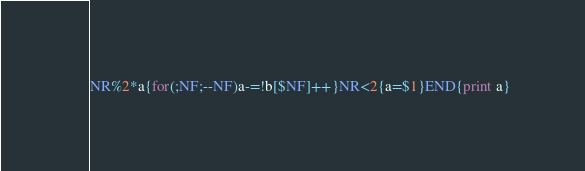Convert code to text. <code><loc_0><loc_0><loc_500><loc_500><_Awk_>NR%2*a{for(;NF;--NF)a-=!b[$NF]++}NR<2{a=$1}END{print a}</code> 